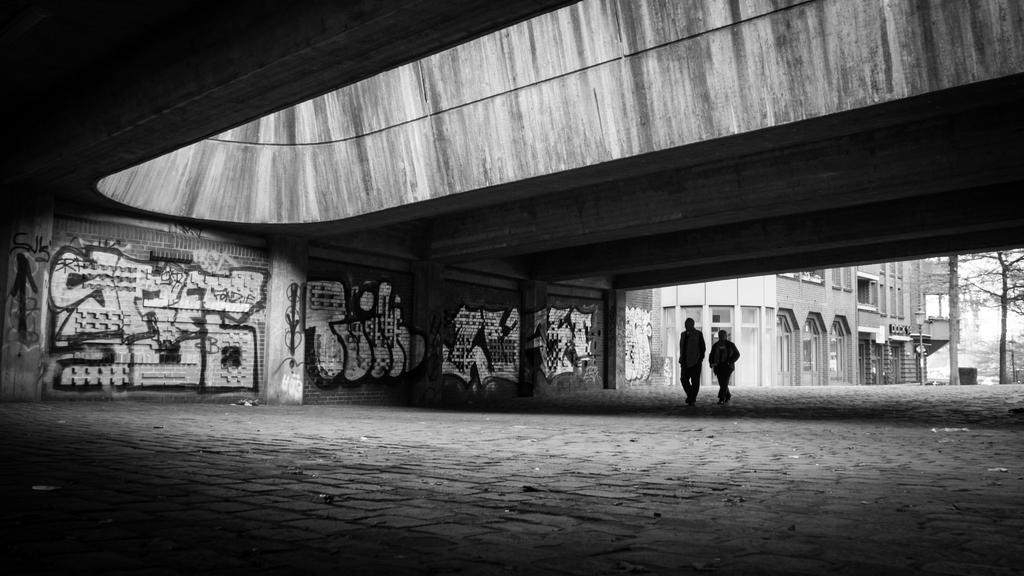Who or what can be seen in the image? There are people in the image. What is on the wall in the image? There are arts on the wall. What can be seen in the background of the image? There is a building and trees in the background of the image. How many clams are sitting on the table in the image? There are no clams present in the image. What does the person in the image wish for? There is no indication of a person making a wish in the image. 